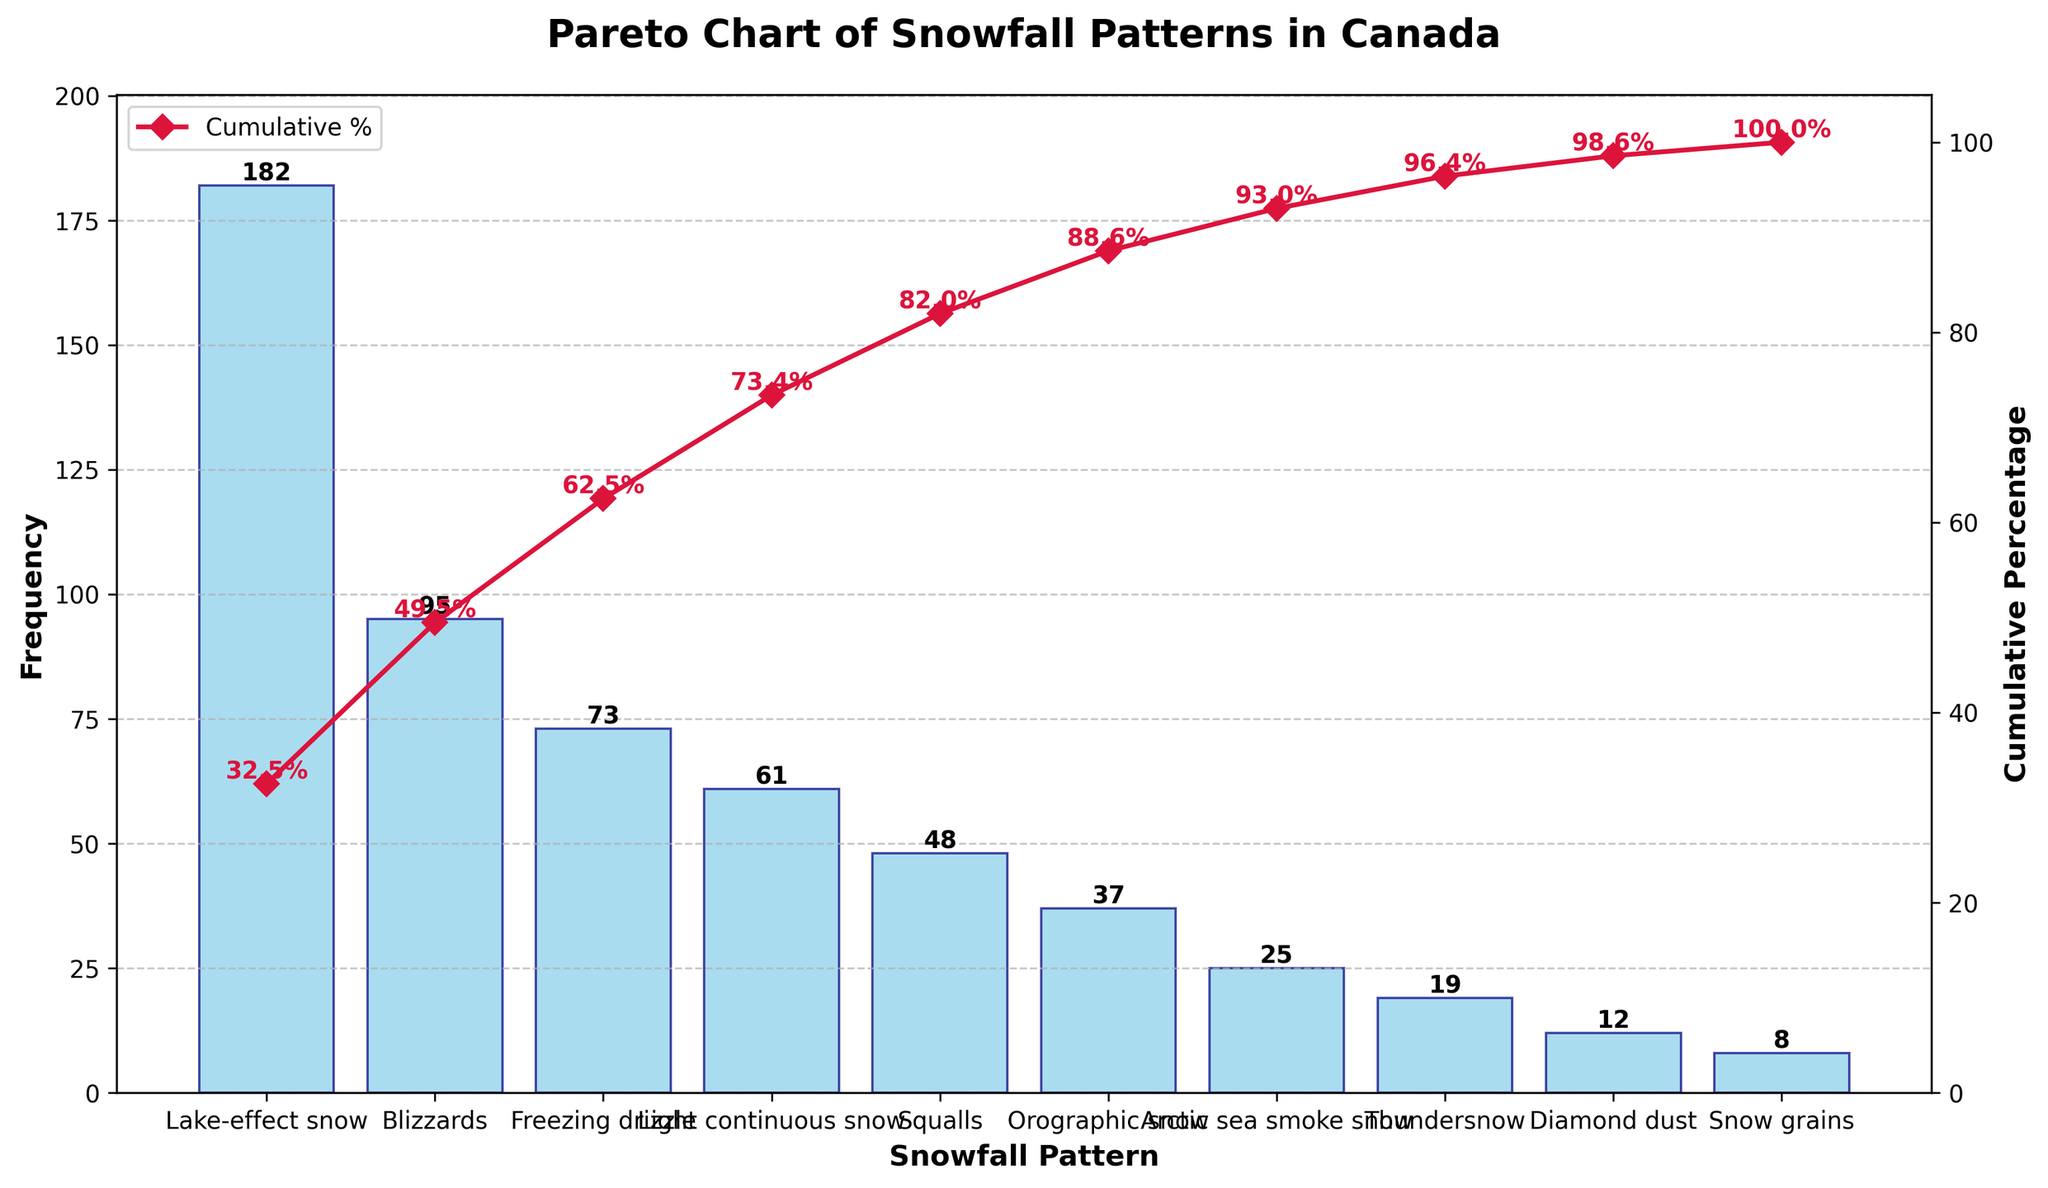What is the most frequent snowfall pattern observed in Canada? The most frequent snowfall pattern is the one with the highest bar on the chart. The tallest bar corresponds to "Lake-effect snow" with a frequency of 182.
Answer: Lake-effect snow What is the cumulative percentage after the first three snowfall patterns are combined? Find the cumulative percentage values for the first three bars which are "Lake-effect snow," "Blizzards," and "Freezing drizzle". Their cumulative percentages are approximately 42.5%, 63.7%, and 81.8% respectively. So, the cumulative percentage after the first three snowfall patterns is about 81.8%.
Answer: 81.8% Which snowfall pattern has a frequency closest to 50? To find the snowfall pattern closest to a frequency of 50, locate the bar whose height is nearest to this value. "Squalls" has a frequency of 48, which is closest to 50.
Answer: Squalls How many snowfall patterns have a frequency less than 20? Count the bars with frequency values less than 20 based on their heights. "Thundersnow," "Diamond dust," and "Snow grains" have frequencies of 19, 12, and 8 respectively, so there are 3 patterns.
Answer: 3 At which snowfall pattern does the cumulative percentage surpass 90%? Identify the point on the cumulative line where it first goes beyond the 90% mark. From the chart, the cumulative percentage surpasses 90% after "Orographic snow," which reaches 91.2%.
Answer: Orographic snow What is the total frequency of the four least common snowfall patterns? Add up the frequencies of the four lowest bars: "Snow grains" (8), "Diamond dust" (12), "Thundersnow" (19), and "Arctic sea smoke snow" (25). Their total is 8 + 12 + 19 + 25 = 64.
Answer: 64 Which snowfall pattern contributes exactly 25% to the cumulative percentage? Examine the cumulative percentage values along the plotted line to find the point that equals 25%. "Freezing drizzle" reaches approximately 25% cumulative percentage.
Answer: Freezing drizzle How many snowfall patterns have a cumulative percentage below 60%? Count the bars for which the cumulative percentage is less than 60% by examining their respective cumulative values. "Lake-effect snow" (42.5%) and "Blizzards" (63.7%) show that two patterns are below 60%.
Answer: 2 Are there more snowfall patterns with frequencies above 20 or below 20? Count bars with frequencies above 20 and those below 20. Frequencies above 20: 7 patterns (everything except "Diamond dust" and "Snow grains"). Frequencies below 20: 2 patterns. Thus, there are more snowfall patterns with frequencies above 20.
Answer: Above 20 Which snowfall pattern marks the halfway (50th percentile) point of the cumulative percentage? Locate on the cumulative line the point where it first equals or surpasses 50%. "Blizzards" has a cumulative percentage around 63.7%, making it slightly above the halfway point (50th percentile).
Answer: Blizzards 